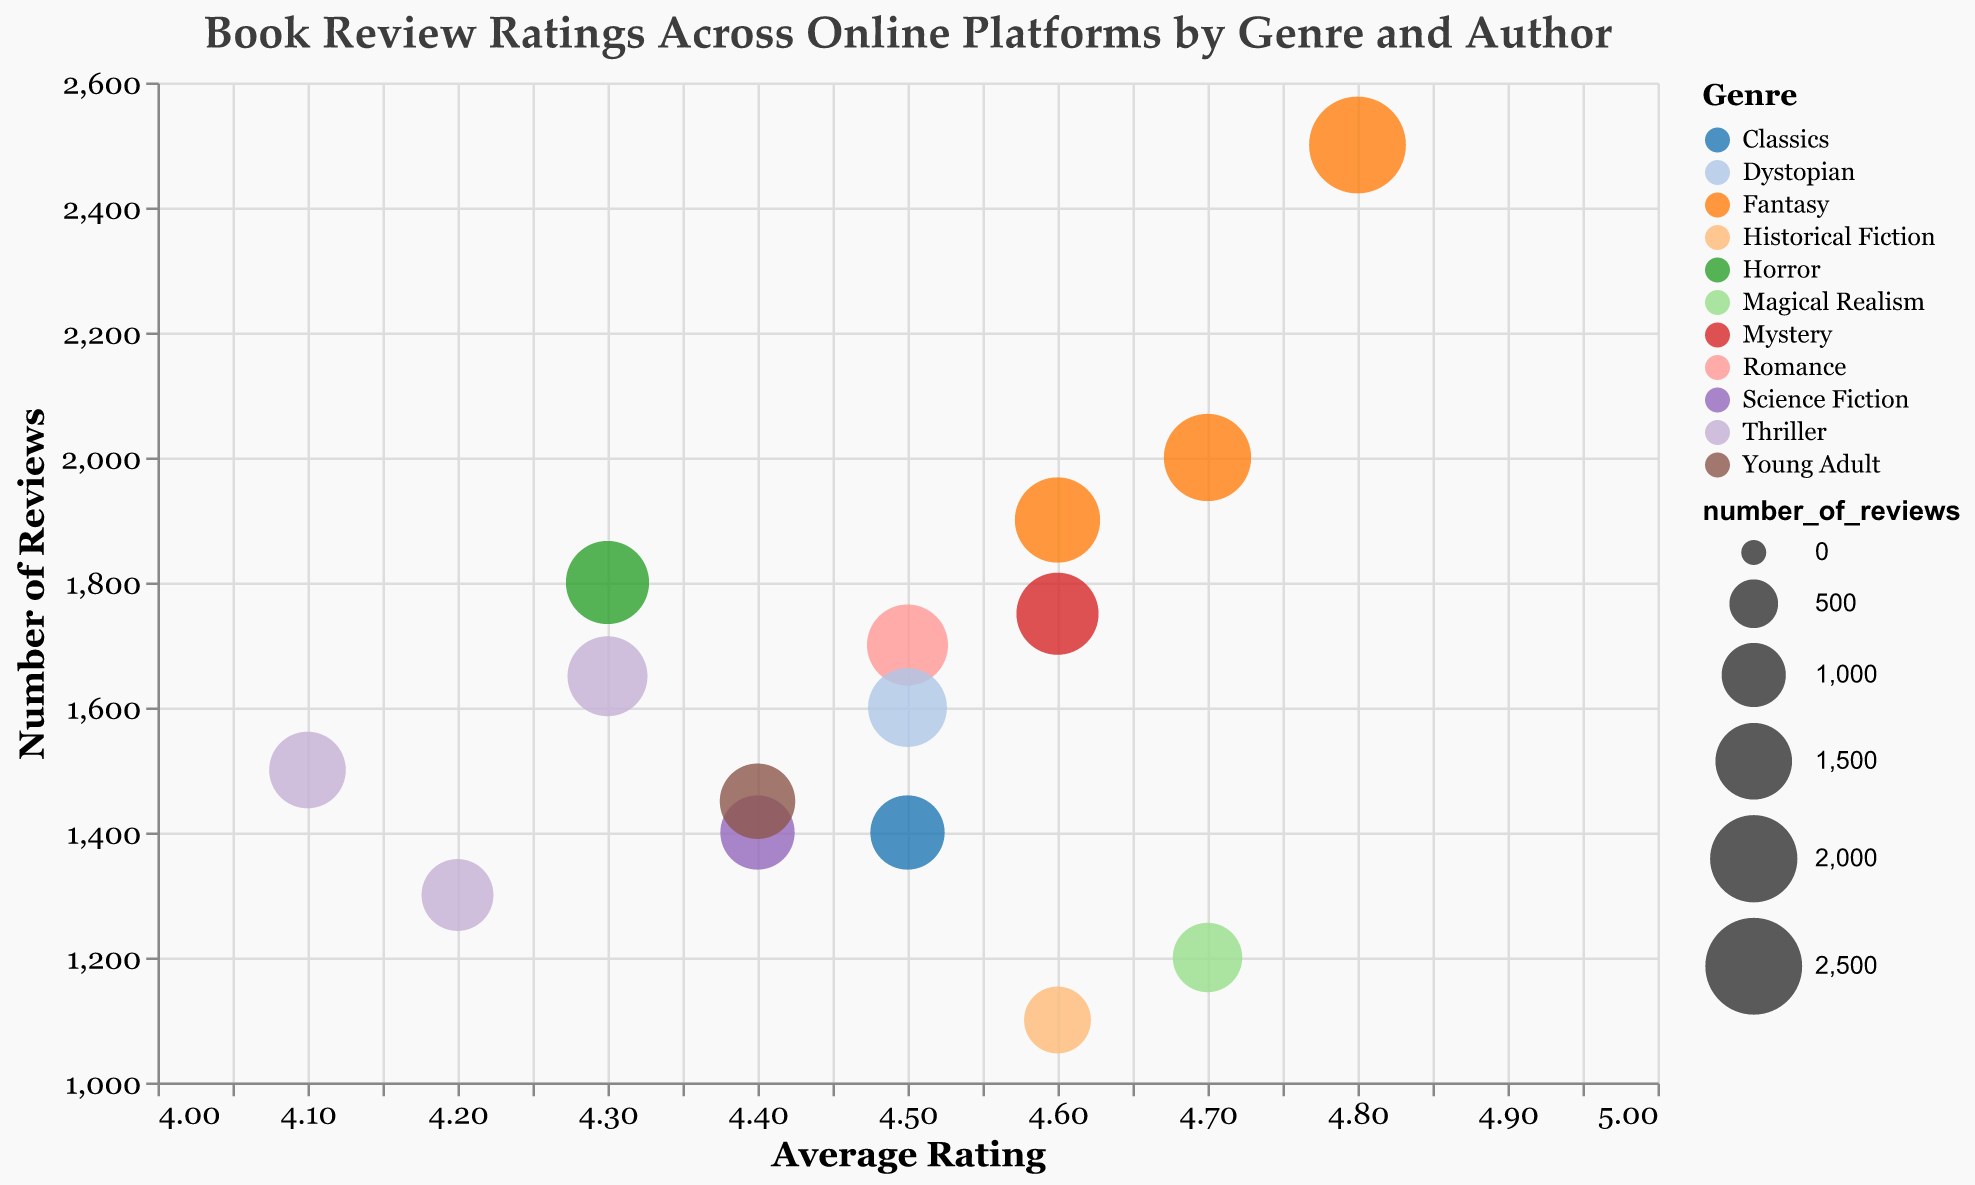What is the average rating of books by George R.R. Martin on Goodreads? George R.R. Martin's data point on the bubble chart shows an average rating of 4.8 on Goodreads.
Answer: 4.8 Which genre has the highest number of reviews for a single author, and who is that author? The largest bubble on the chart represents George R.R. Martin in the Fantasy genre with 2500 reviews.
Answer: Fantasy, George R.R. Martin How many books in the Romance category and the Historical Fiction category have an average rating above 4.5? Nora Roberts (Romance) has a 4.5 rating, and Isabel Allende (Historical Fiction) has a 4.6 rating. Only Isabel Allende has a rating above 4.5, so 1 book in both categories combined.
Answer: 1 Who has more reviews, Stephen King or Cassandra Clare, and by how many? Stephen King's data point shows 1800 reviews, while Cassandra Clare's shows 1450 reviews. The difference is 1800 - 1450 = 350.
Answer: Stephen King, by 350 reviews What is the average rating of all authors in the Fantasy genre? The Fantasy genre includes J.K. Rowling (4.7), George R.R. Martin (4.8), and Neil Gaiman (4.6). Average rating = (4.7 + 4.8 + 4.6) / 3 = 4.7
Answer: 4.7 Which author has the lowest average rating, and what platform are they on? James Patterson's data point shows the lowest average rating of 4.1, and he is on Goodreads.
Answer: James Patterson, Goodreads Compare the number of reviews for books by Douglas Adams and Haruki Murakami. Who has more, and what are the numbers? Douglas Adams' data point shows 1400 reviews, while Haruki Murakami's shows 1200 reviews. Douglas Adams has more reviews.
Answer: Douglas Adams, 1400 vs 1200 Which genre has the most number of reviews in total on Amazon? Amazon platform includes J.K. Rowling (2000), Nora Roberts (1700), Douglas Adams (1400), Neil Gaiman (1900), Dan Brown (1650), and Cassandra Clare (1450). Total reviews = 2000 + 1700 + 1400 + 1900 + 1650 + 1450 = 10100.
Answer: Amazon (total 10100 reviews) Which author on Barnes & Noble has the highest average rating, and what is the rating? Haruki Murakami's data point on Barnes & Noble shows the highest average rating of 4.7.
Answer: Haruki Murakami, 4.7 What is the difference in average ratings between Agatha Christie and Stephen King? Agatha Christie has an average rating of 4.6, and Stephen King has an average rating of 4.3. The difference is 4.6 - 4.3 = 0.3.
Answer: 0.3 